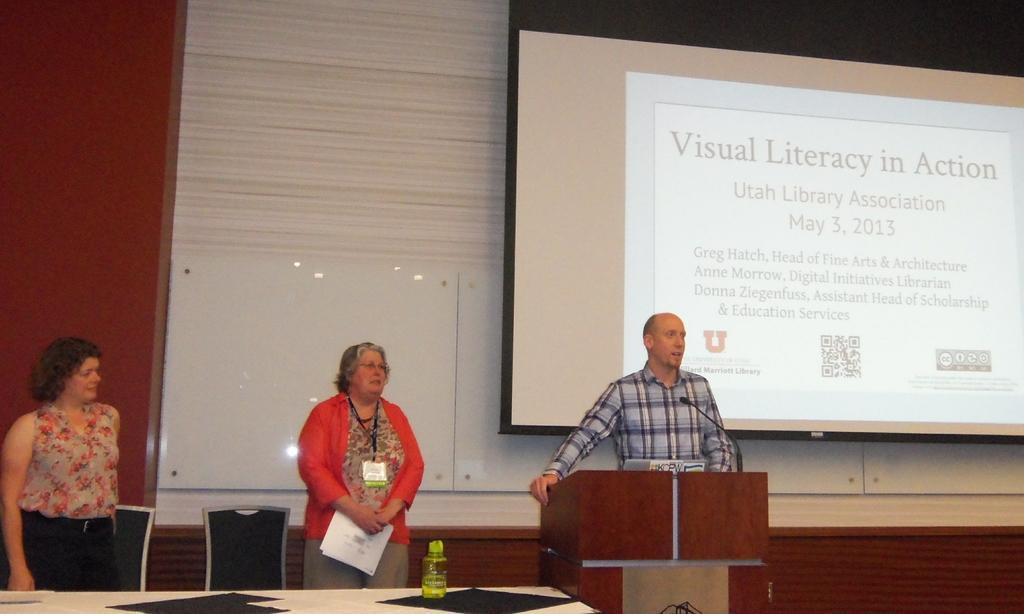How would you summarize this image in a sentence or two? There is a person standing in front of a wooden desk and he is speaking on a microphone. There are two women who are standing on the left side. This is a screen. 